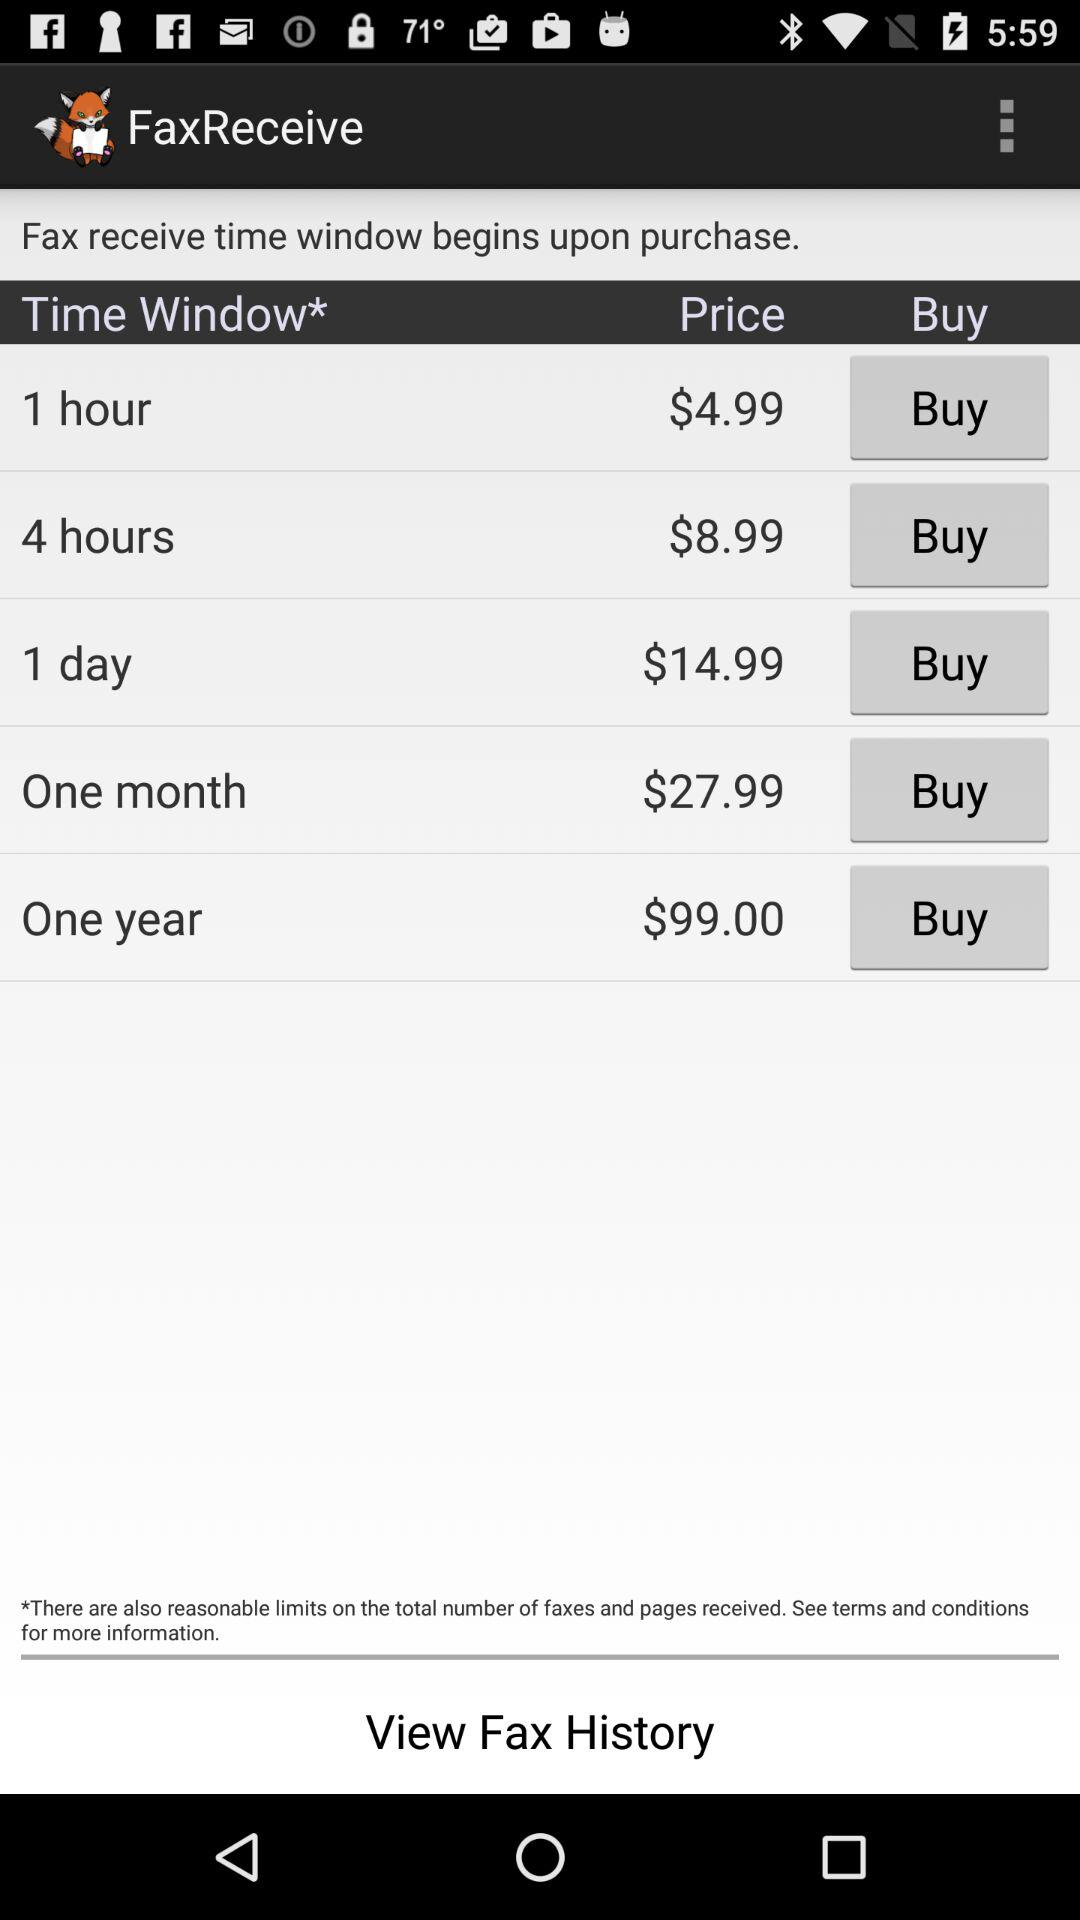What is the currency used for the price? The currency used for the price is "$". 